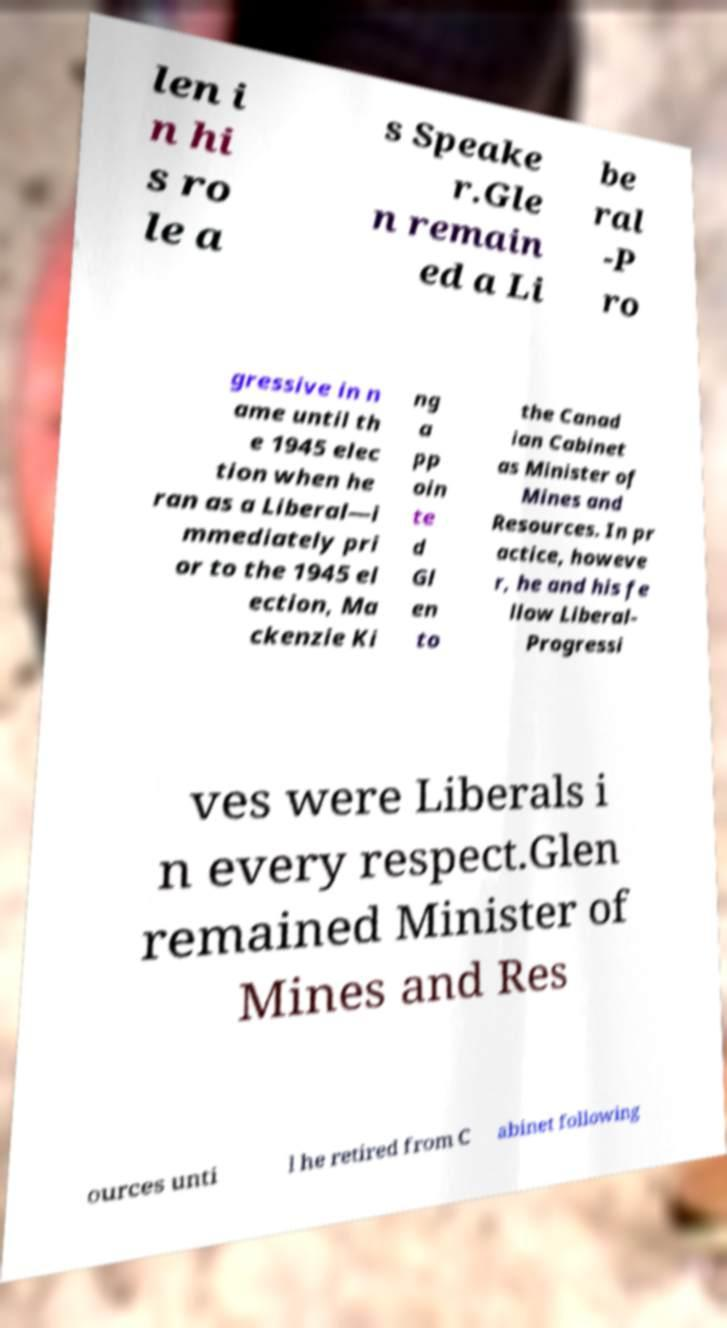I need the written content from this picture converted into text. Can you do that? len i n hi s ro le a s Speake r.Gle n remain ed a Li be ral -P ro gressive in n ame until th e 1945 elec tion when he ran as a Liberal—i mmediately pri or to the 1945 el ection, Ma ckenzie Ki ng a pp oin te d Gl en to the Canad ian Cabinet as Minister of Mines and Resources. In pr actice, howeve r, he and his fe llow Liberal- Progressi ves were Liberals i n every respect.Glen remained Minister of Mines and Res ources unti l he retired from C abinet following 